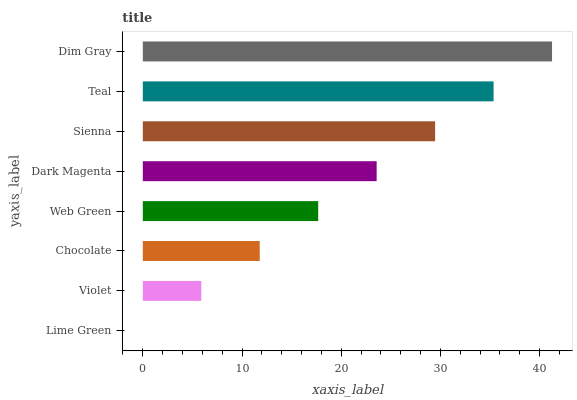Is Lime Green the minimum?
Answer yes or no. Yes. Is Dim Gray the maximum?
Answer yes or no. Yes. Is Violet the minimum?
Answer yes or no. No. Is Violet the maximum?
Answer yes or no. No. Is Violet greater than Lime Green?
Answer yes or no. Yes. Is Lime Green less than Violet?
Answer yes or no. Yes. Is Lime Green greater than Violet?
Answer yes or no. No. Is Violet less than Lime Green?
Answer yes or no. No. Is Dark Magenta the high median?
Answer yes or no. Yes. Is Web Green the low median?
Answer yes or no. Yes. Is Teal the high median?
Answer yes or no. No. Is Violet the low median?
Answer yes or no. No. 